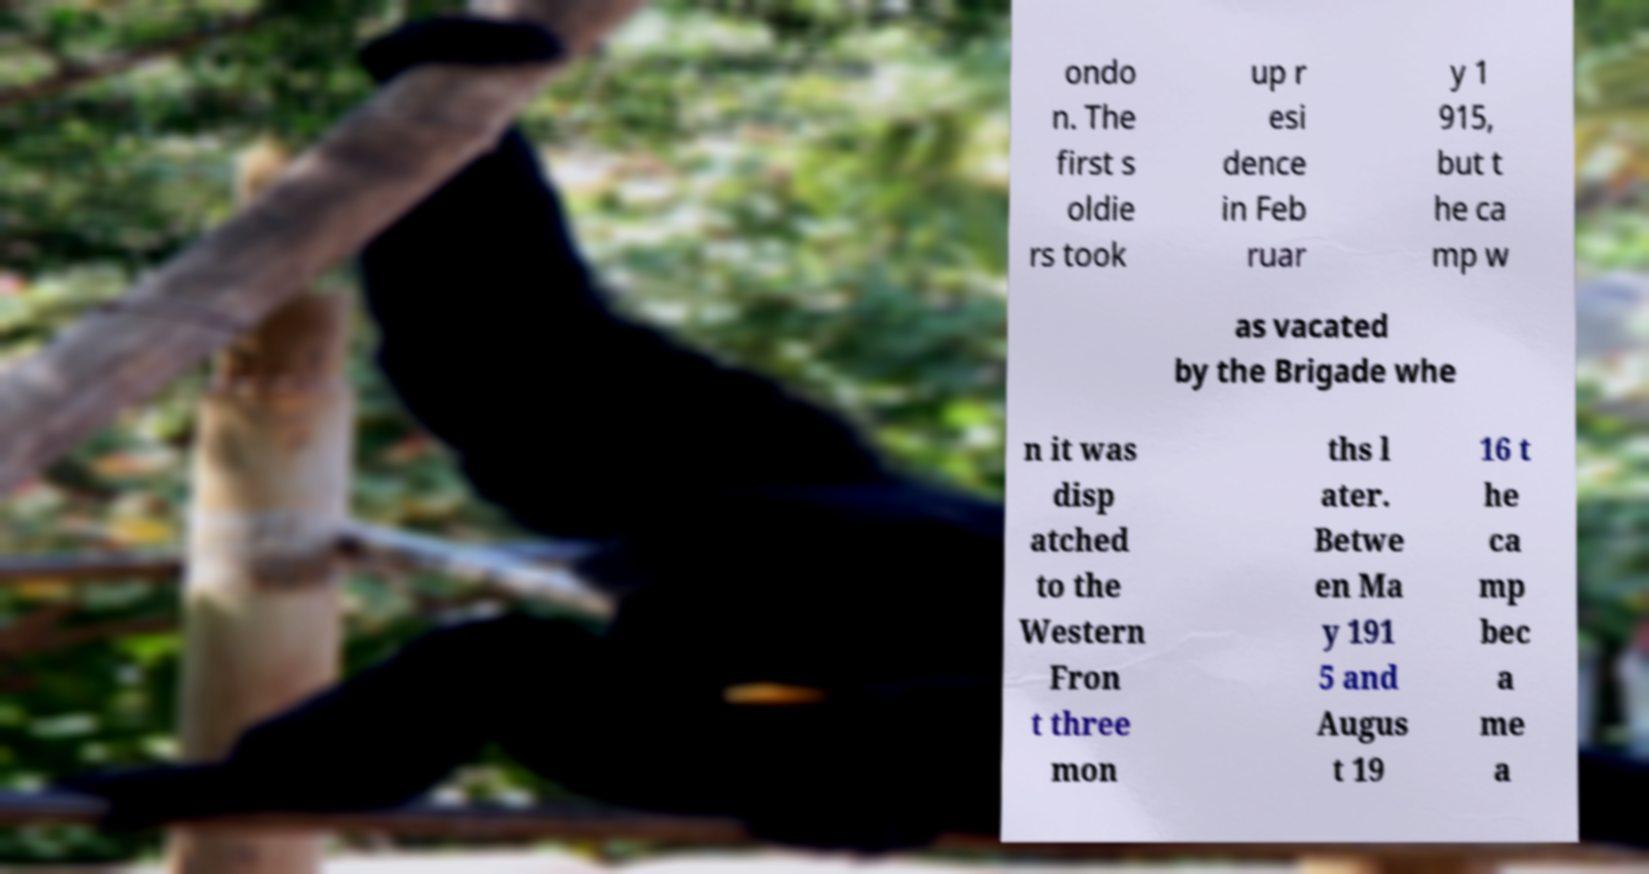Please identify and transcribe the text found in this image. ondo n. The first s oldie rs took up r esi dence in Feb ruar y 1 915, but t he ca mp w as vacated by the Brigade whe n it was disp atched to the Western Fron t three mon ths l ater. Betwe en Ma y 191 5 and Augus t 19 16 t he ca mp bec a me a 